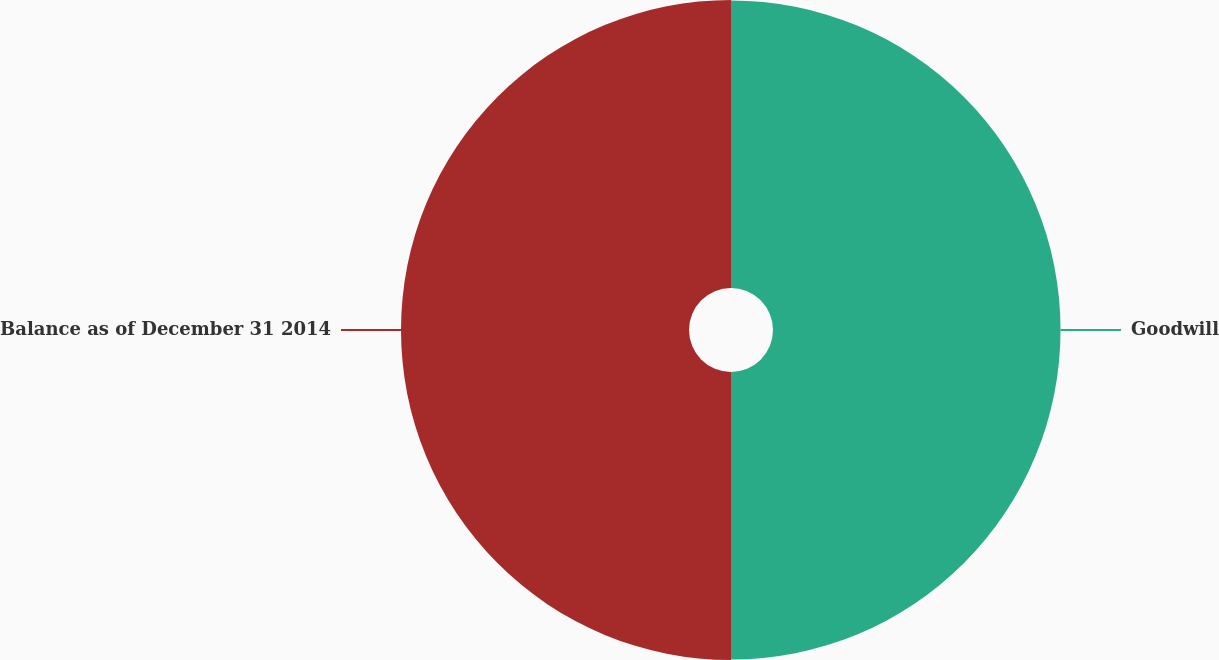Convert chart. <chart><loc_0><loc_0><loc_500><loc_500><pie_chart><fcel>Goodwill<fcel>Balance as of December 31 2014<nl><fcel>49.96%<fcel>50.04%<nl></chart> 